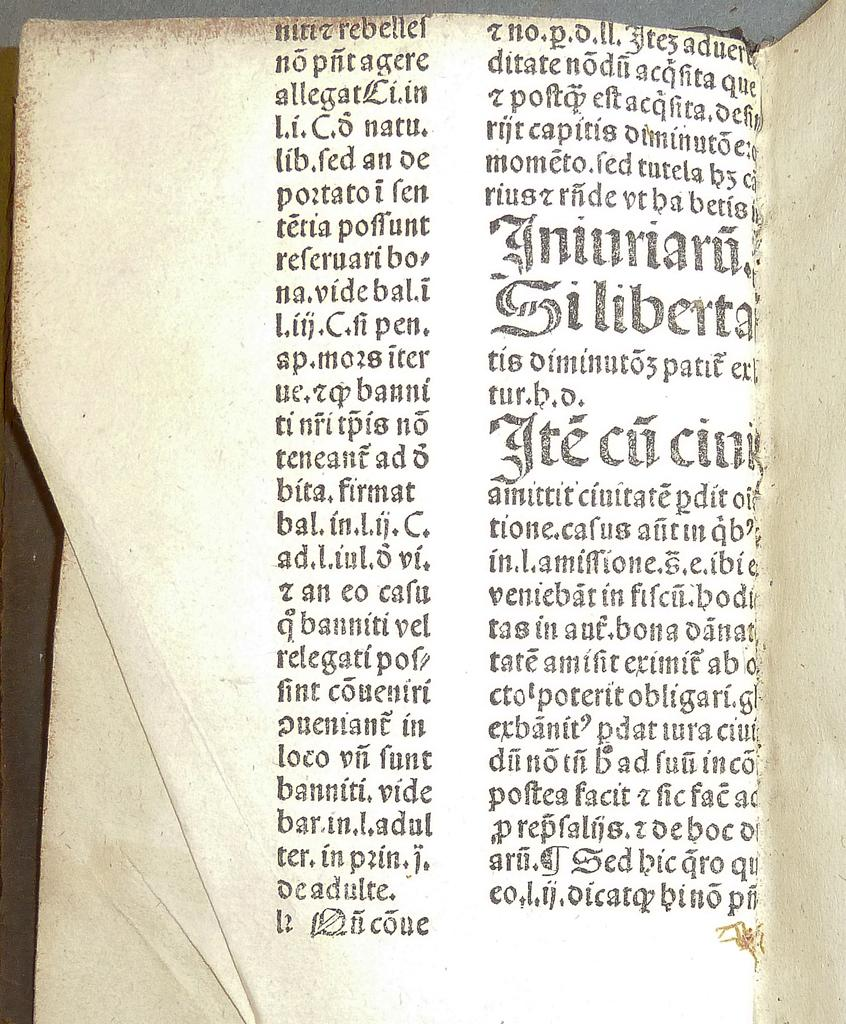What object is placed on the table in the image? There is a book on the table in the image. What is inside the book? The book contains an article. Can you describe anything else in the image? Yes, there is a spider in the bottom right corner of the image. What type of reward is the spider holding in the image? There is no reward present in the image, and the spider is not holding anything. 